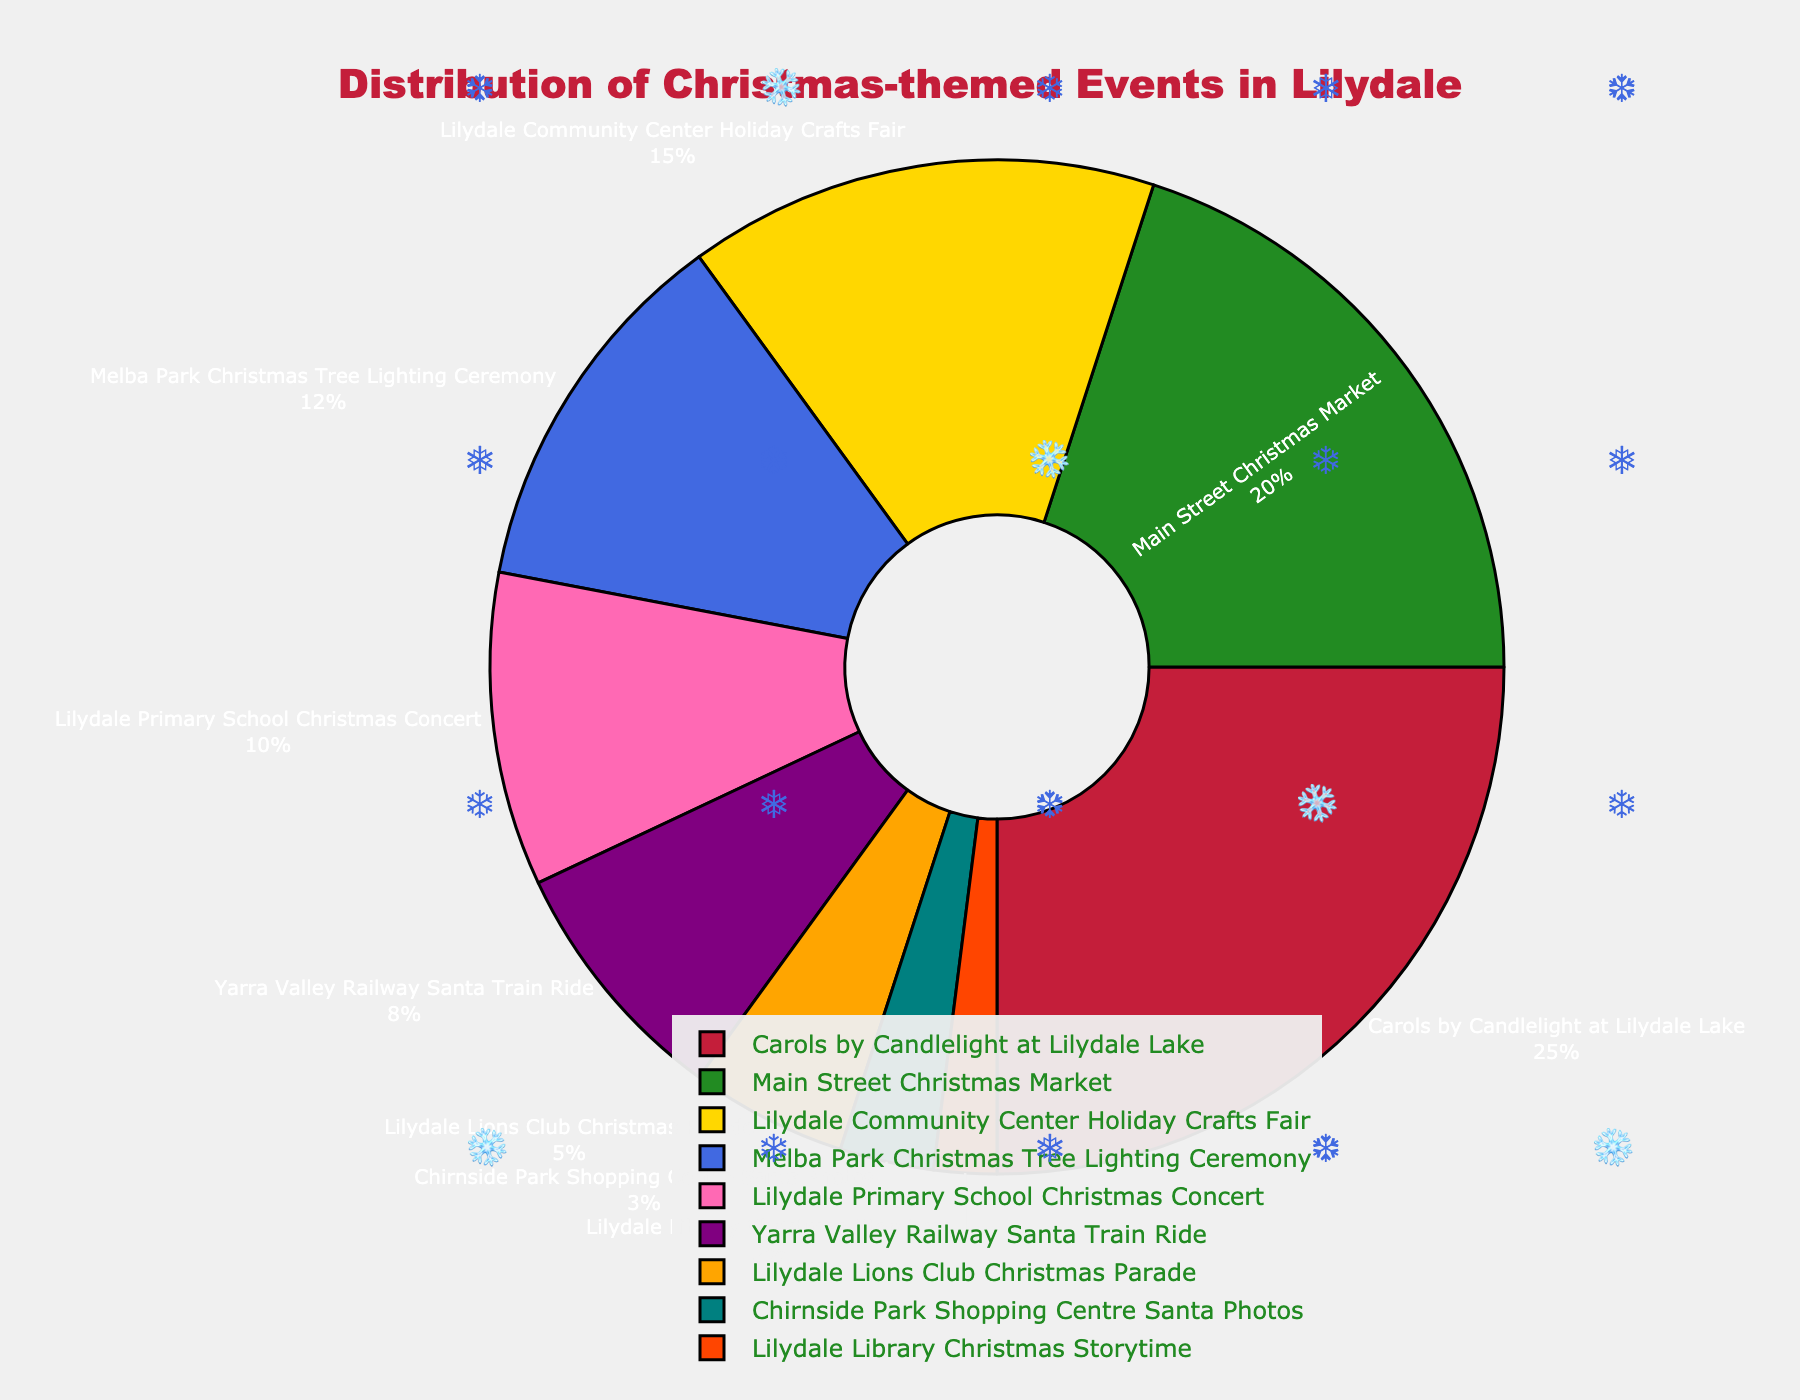what event has the highest percentage? The event with the highest percentage is the Carols by Candlelight at Lilydale Lake, constituting 25% of the total events.
Answer: Carols by Candlelight at Lilydale Lake which two events together make up 35% of the events? The Main Street Christmas Market accounts for 20% and Lilydale Community Center Holiday Crafts Fair accounts for 15%. Together, they make up 35%.
Answer: Main Street Christmas Market and Lilydale Community Center Holiday Crafts Fair how much more is the percentage of the Lilydale Primary School Christmas Concert compared to the Lilydale Lions Club Christmas Parade? The percentage of the Lilydale Primary School Christmas Concert is 10% and the Lilydale Lions Club Christmas Parade is 5%. The difference is 10% - 5%.
Answer: 5% what is the combined percentage of the bottom three events? The bottom three events are: Chirnside Park Shopping Centre Santa Photos (3%), Lilydale Library Christmas Storytime (2%), and Lilydale Lions Club Christmas Parade (5%). Their combined percentage is 3% + 2% + 5%.
Answer: 10% which event has a visual marker in orange? According to the visual properties in the figure, the Lilydale Lions Club Christmas Parade is represented by the color orange.
Answer: Lilydale Lions Club Christmas Parade Is the percentage of the Yarra Valley Railway Santa Train Ride greater than the Melba Park Christmas Tree Lighting Ceremony? The Yarra Valley Railway Santa Train Ride is 8%, which is less than the Melba Park Christmas Tree Lighting Ceremony at 12%.
Answer: No Among the events, which one has the smallest percentage and what is it? The Lilydale Library Christmas Storytime has the smallest percentage at 2%.
Answer: Lilydale Library Christmas Storytime, 2% what is the aggregate percentage of all events except for the Main Street Christmas Market and Carols by Candlelight at Lilydale Lake? Subtract the Main Street Christmas Market (20%) and Carols by Candlelight at Lilydale Lake (25%) from 100%.
Answer: 55% what percentage of the events are organized by the Lilydale Community Center or Lilydale Primary School? Lilydale Community Center Holiday Crafts Fair is 15% and Lilydale Primary School Christmas Concert is 10%. Combined, they account for 25%.
Answer: 25% which event depicted in light blue has what percentage? By referencing the figure, the Melba Park Christmas Tree Lighting Ceremony is shown in light blue and is 12%.
Answer: Melba Park Christmas Tree Lighting Ceremony, 12% 